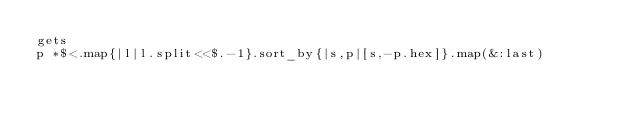<code> <loc_0><loc_0><loc_500><loc_500><_Ruby_>gets
p *$<.map{|l|l.split<<$.-1}.sort_by{|s,p|[s,-p.hex]}.map(&:last)</code> 